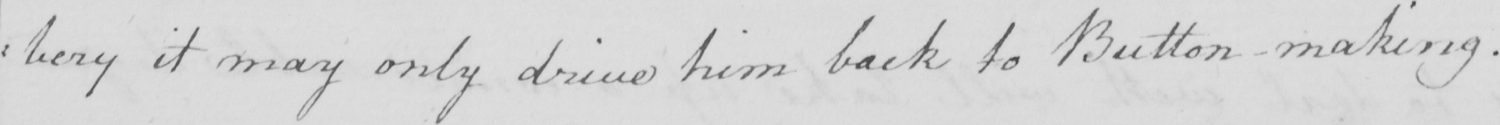Can you read and transcribe this handwriting? : bery it may only drive him back to Button making . 